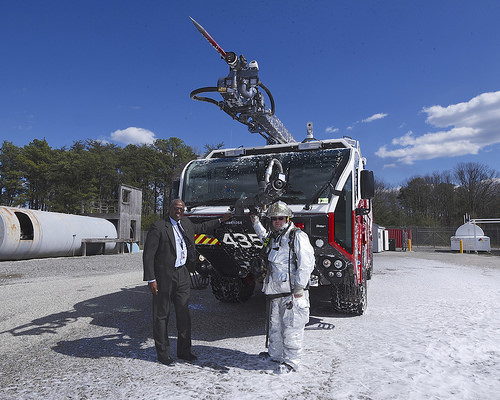<image>
Is there a suited man behind the snowsuit man? No. The suited man is not behind the snowsuit man. From this viewpoint, the suited man appears to be positioned elsewhere in the scene. Is the ladder next to the man? No. The ladder is not positioned next to the man. They are located in different areas of the scene. 